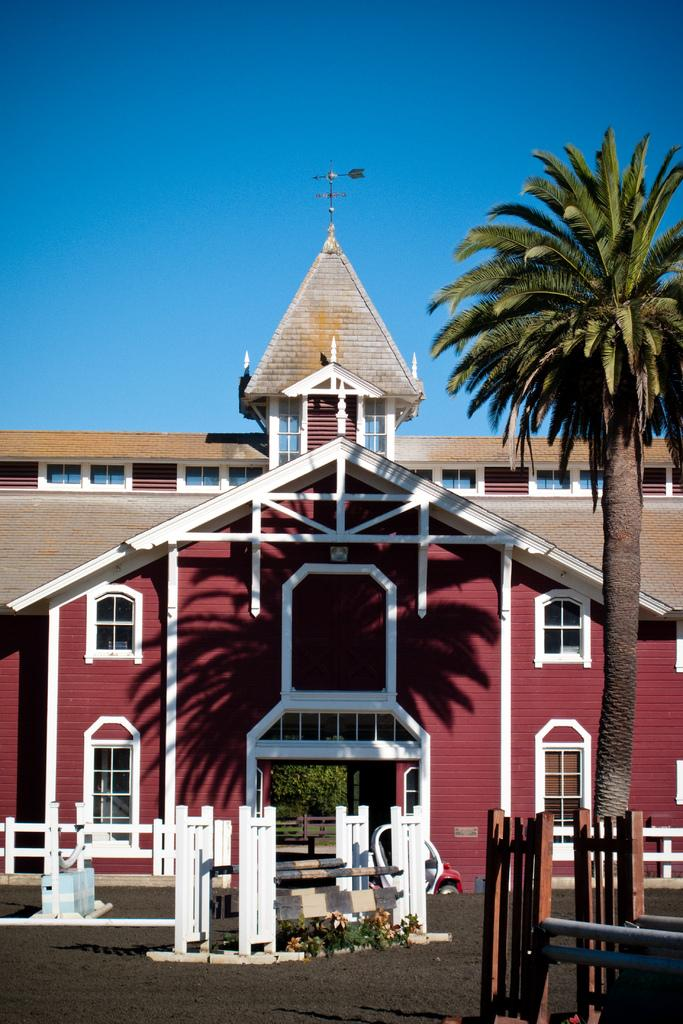What type of fencing can be seen on both sides of the image? There is a wooden fence on both the right and left sides of the image. What other natural element is present on the right side of the image? There is a tree on the right side of the image. What type of structure is visible in the image? There is a house in the image. What is the condition of the sky in the image? The sky is clear in the image. Where is the tub located in the image? There is no tub present in the image. What type of tin is used to cover the tree in the image? There is no tin covering the tree in the image; it is a natural tree. 